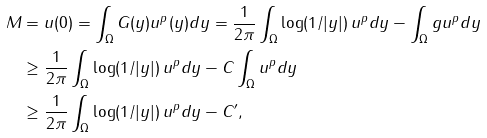<formula> <loc_0><loc_0><loc_500><loc_500>M & = u ( 0 ) = \int _ { \Omega } G ( y ) u ^ { p } ( y ) d y = \frac { 1 } { 2 \pi } \int _ { \Omega } \log ( 1 / | y | ) \, u ^ { p } d y - \int _ { \Omega } g u ^ { p } d y \\ & \geq \frac { 1 } { 2 \pi } \int _ { \Omega } \log ( 1 / | y | ) \, u ^ { p } d y - C \int _ { \Omega } u ^ { p } d y \\ & \geq \frac { 1 } { 2 \pi } \int _ { \Omega } \log ( 1 / | y | ) \, u ^ { p } d y - C ^ { \prime } ,</formula> 